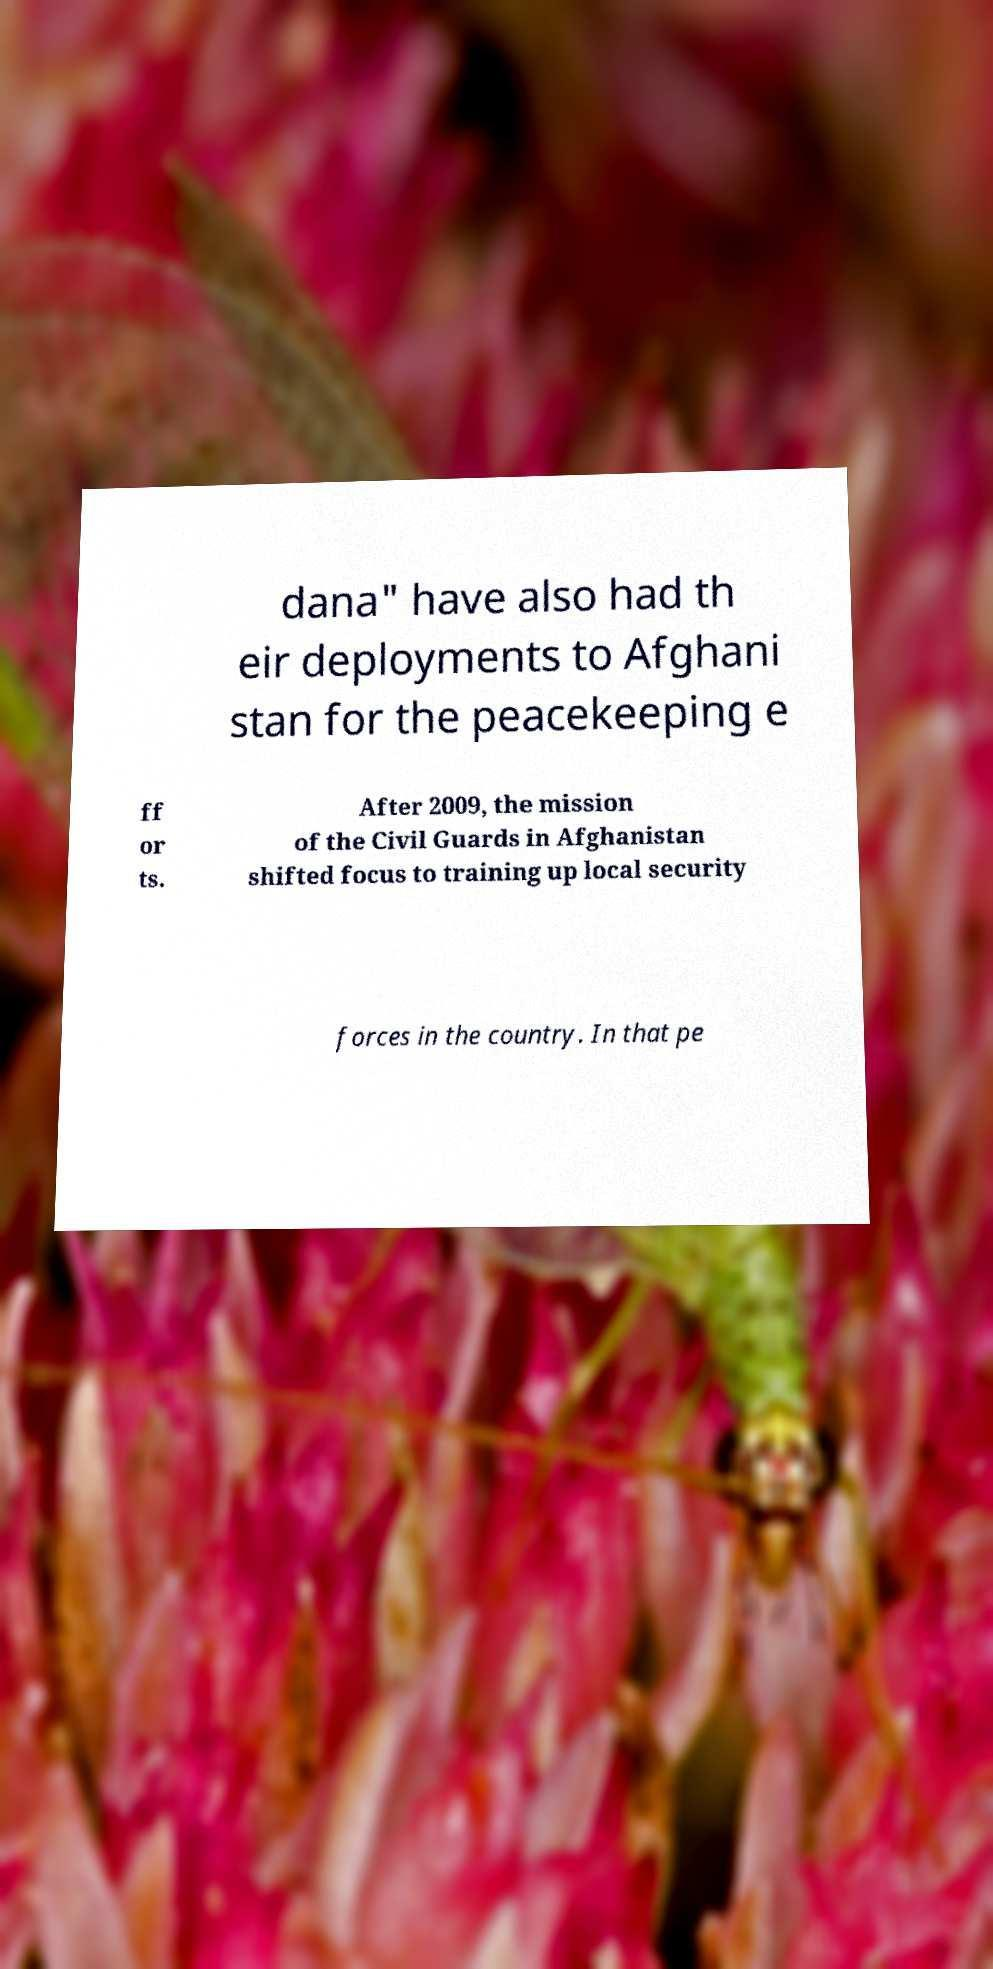For documentation purposes, I need the text within this image transcribed. Could you provide that? dana" have also had th eir deployments to Afghani stan for the peacekeeping e ff or ts. After 2009, the mission of the Civil Guards in Afghanistan shifted focus to training up local security forces in the country. In that pe 